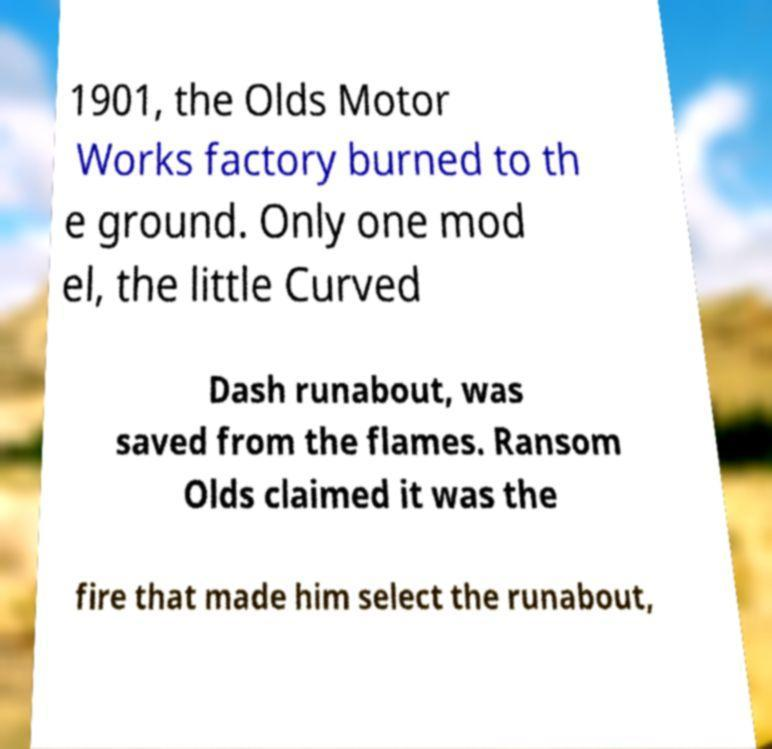Could you extract and type out the text from this image? 1901, the Olds Motor Works factory burned to th e ground. Only one mod el, the little Curved Dash runabout, was saved from the flames. Ransom Olds claimed it was the fire that made him select the runabout, 